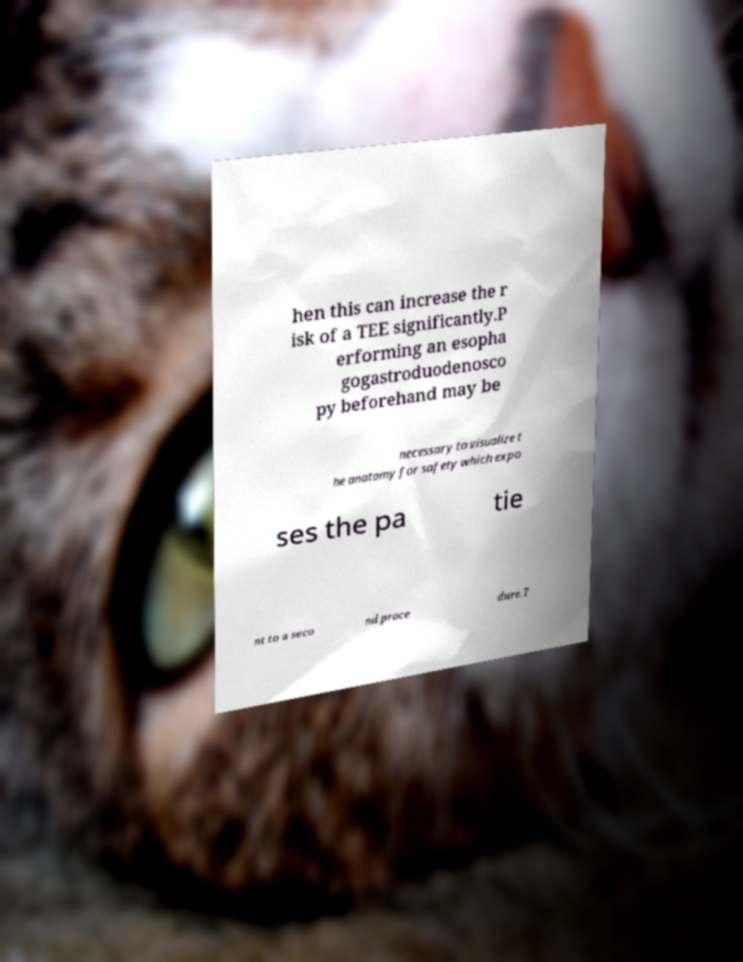Could you assist in decoding the text presented in this image and type it out clearly? hen this can increase the r isk of a TEE significantly.P erforming an esopha gogastroduodenosco py beforehand may be necessary to visualize t he anatomy for safety which expo ses the pa tie nt to a seco nd proce dure.T 